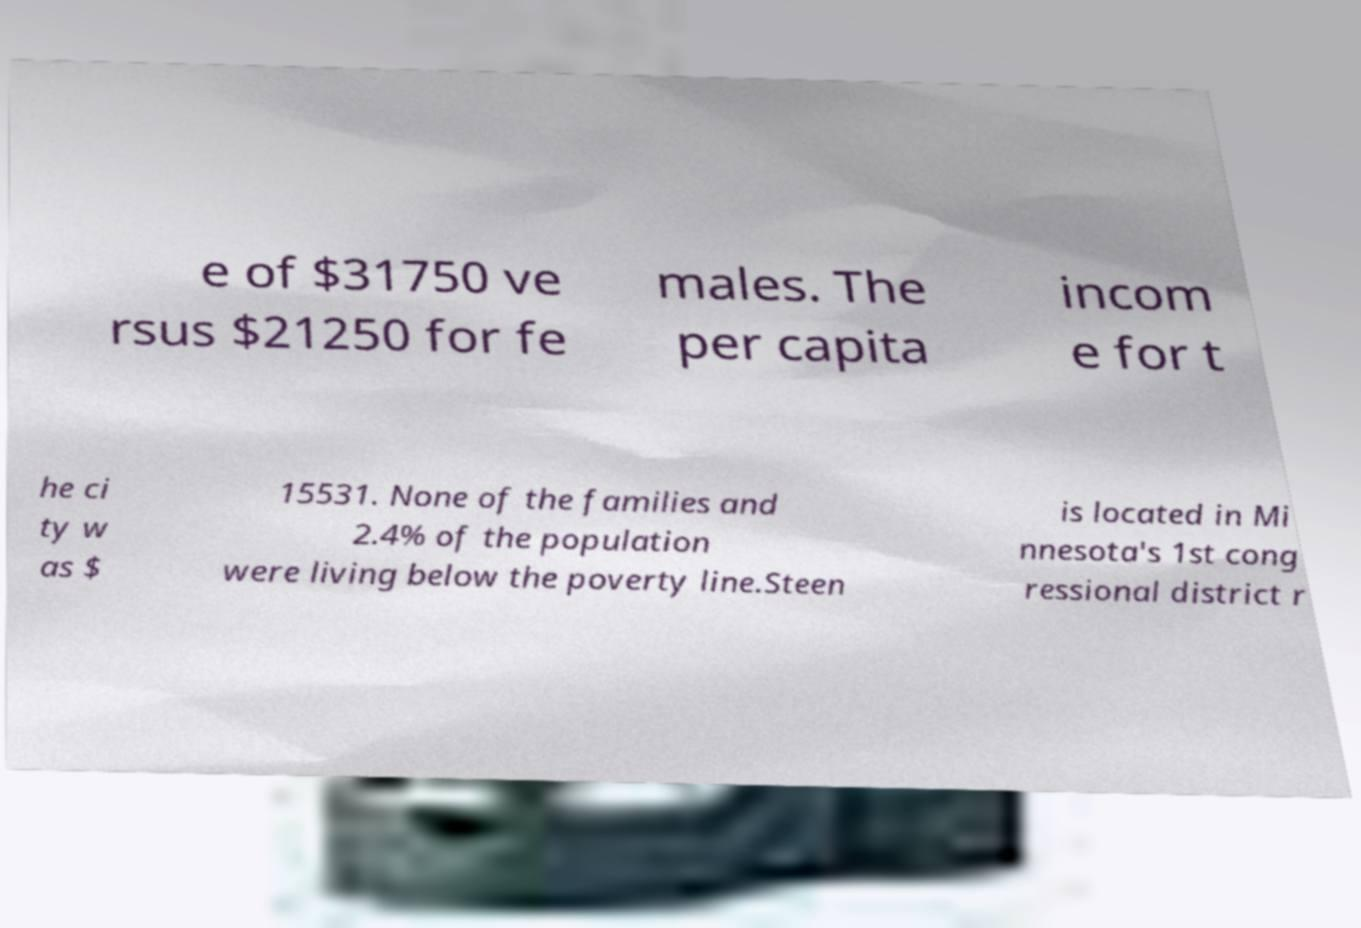I need the written content from this picture converted into text. Can you do that? e of $31750 ve rsus $21250 for fe males. The per capita incom e for t he ci ty w as $ 15531. None of the families and 2.4% of the population were living below the poverty line.Steen is located in Mi nnesota's 1st cong ressional district r 